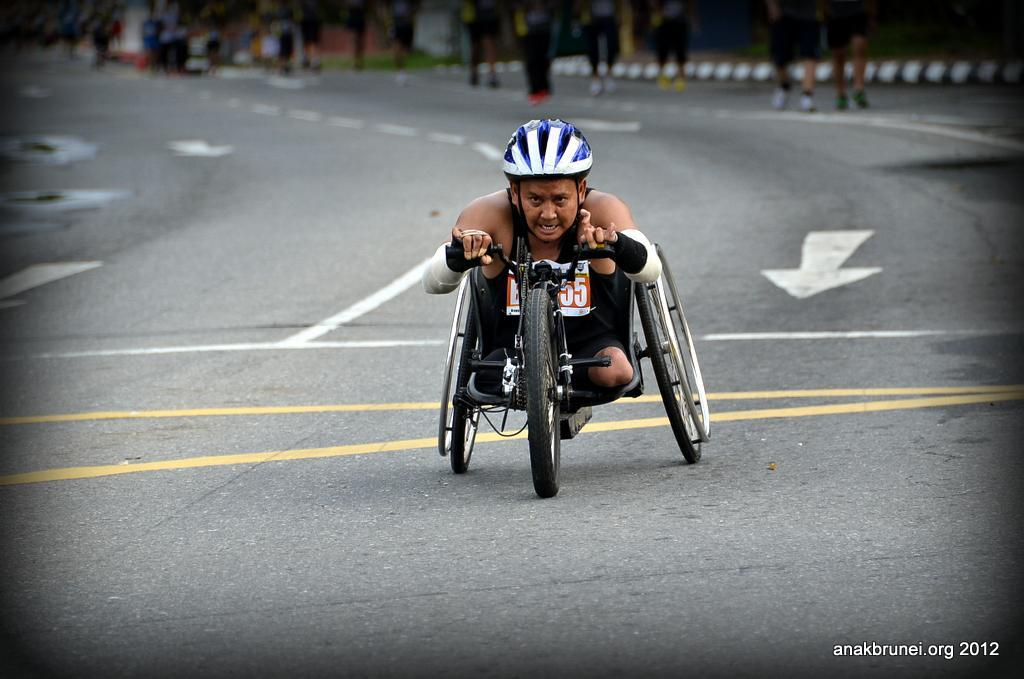What is the man in the image doing? The man is riding a wheelchair in the image. What is the man wearing on his head? The man is wearing a helmet in the image. Where is the wheelchair located? The wheelchair is on the road in the image. What can be seen in the background of the image? There are people walking and trees in the background of the image. How would you describe the quality of the image? The image is blurry. What type of silk fabric is draped over the band in the image? There is no band or silk fabric present in the image. 